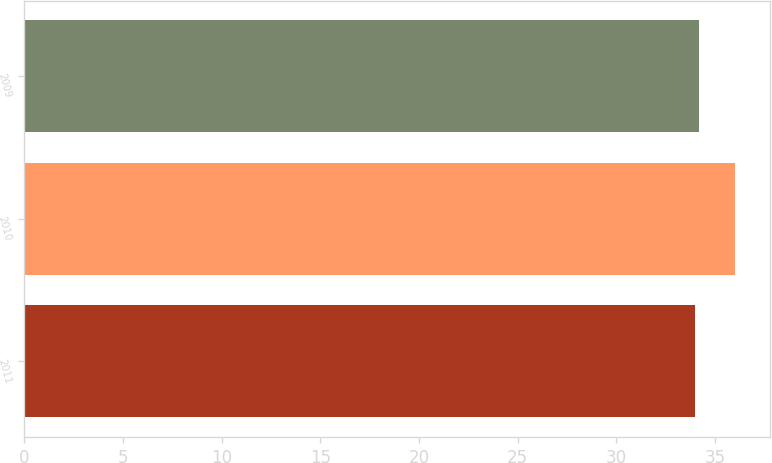<chart> <loc_0><loc_0><loc_500><loc_500><bar_chart><fcel>2011<fcel>2010<fcel>2009<nl><fcel>34<fcel>36<fcel>34.2<nl></chart> 